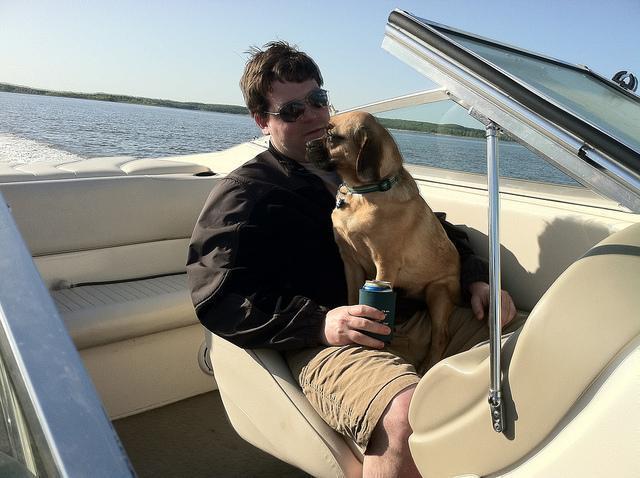How many chairs can you see?
Give a very brief answer. 1. 